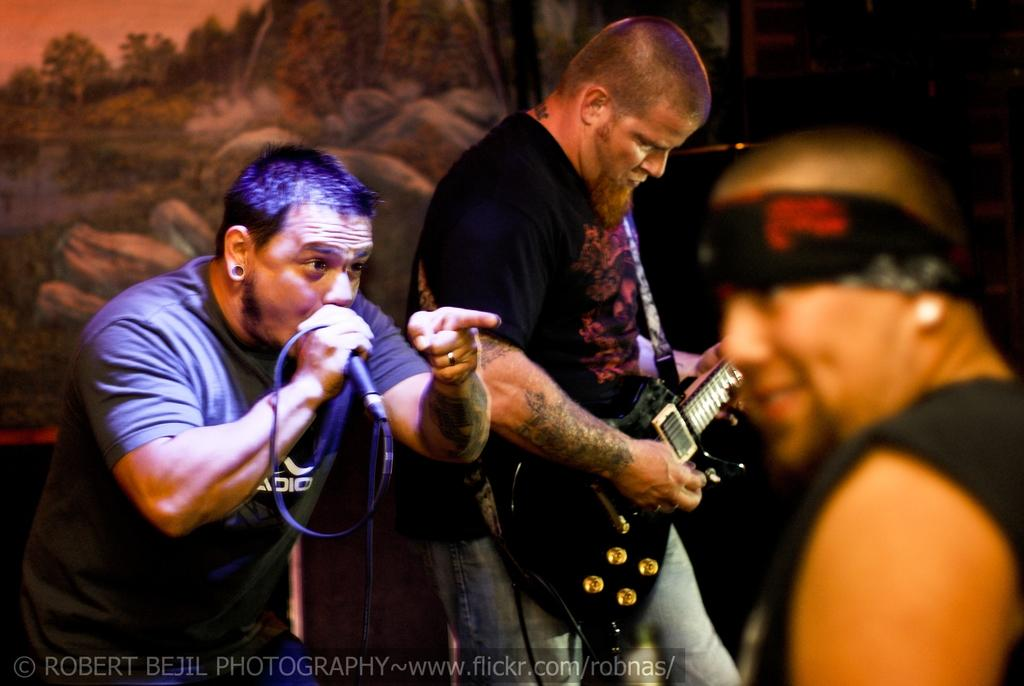How many people are in the image? There are three persons in the image. What is the person wearing a black t-shirt doing? The person in the black t-shirt is playing a guitar. What is the other person holding? Another person is holding a microphone. What can be seen in the background of the image? There is a painting visible in the background of the image. What type of toys can be seen on the floor in the image? There are no toys visible on the floor in the image. How many weeks does the painting in the background depict? The painting in the background does not depict any weeks; it is a static image. 